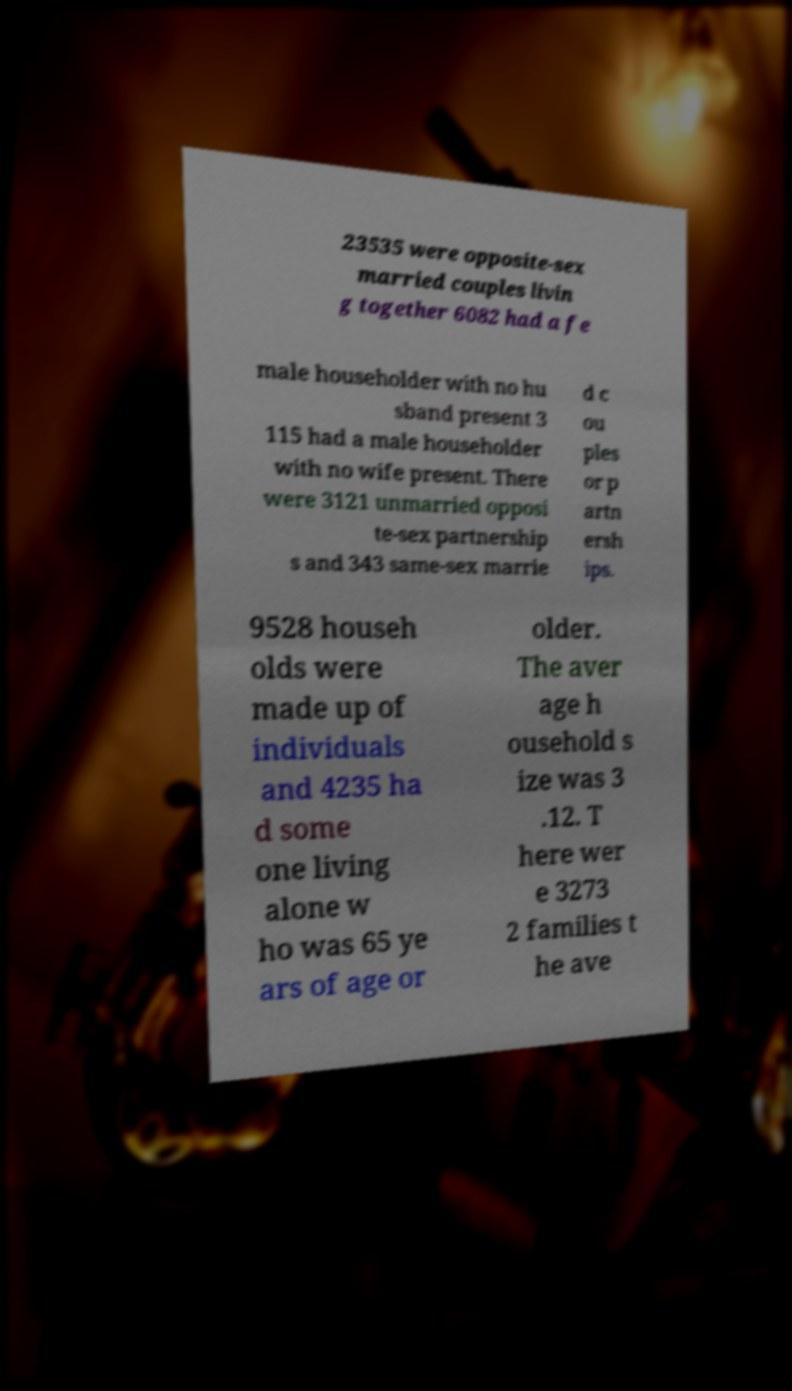Please identify and transcribe the text found in this image. 23535 were opposite-sex married couples livin g together 6082 had a fe male householder with no hu sband present 3 115 had a male householder with no wife present. There were 3121 unmarried opposi te-sex partnership s and 343 same-sex marrie d c ou ples or p artn ersh ips. 9528 househ olds were made up of individuals and 4235 ha d some one living alone w ho was 65 ye ars of age or older. The aver age h ousehold s ize was 3 .12. T here wer e 3273 2 families t he ave 